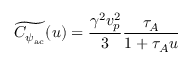<formula> <loc_0><loc_0><loc_500><loc_500>\widetilde { C _ { \psi _ { a c } } } ( u ) = \frac { \gamma ^ { 2 } v _ { p } ^ { 2 } } { 3 } \frac { \tau _ { A } } { 1 + \tau _ { A } u }</formula> 